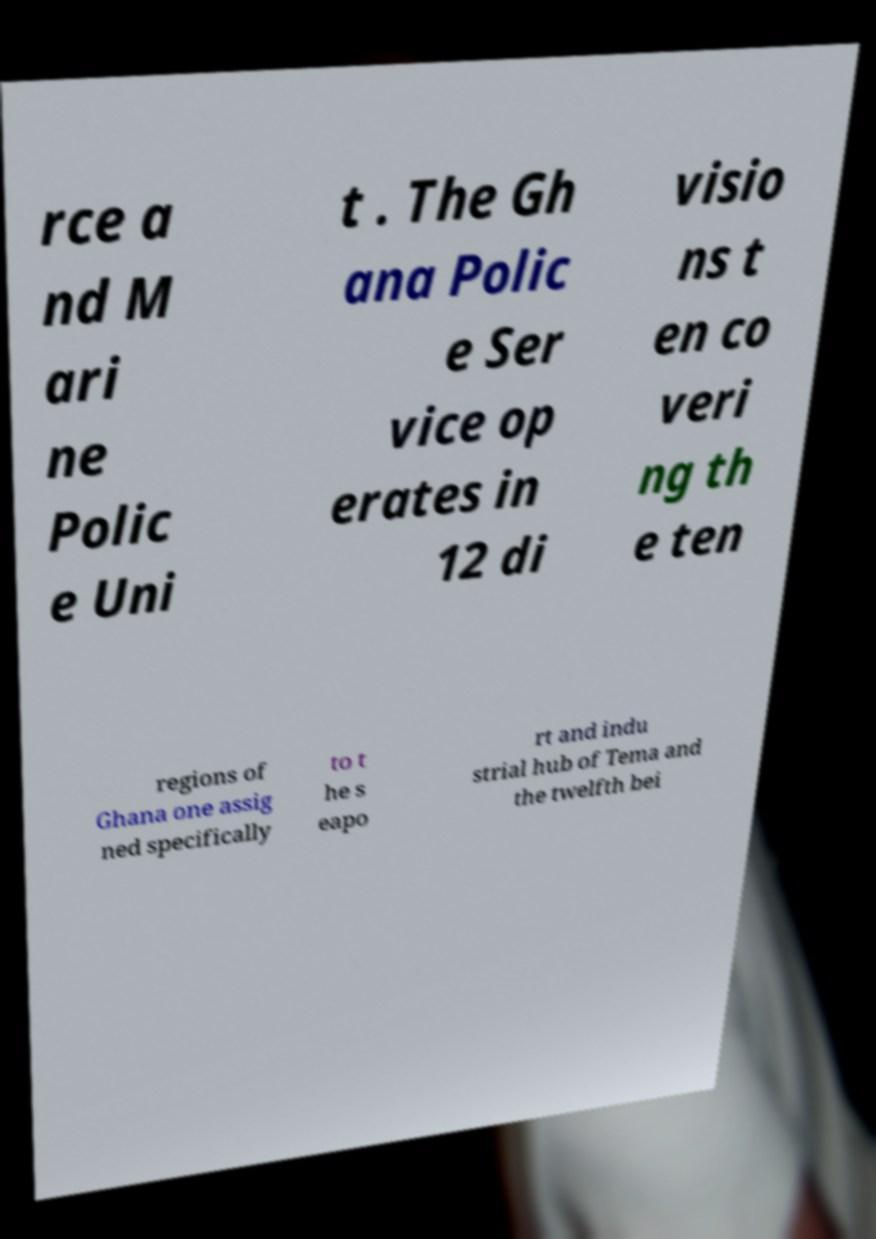There's text embedded in this image that I need extracted. Can you transcribe it verbatim? rce a nd M ari ne Polic e Uni t . The Gh ana Polic e Ser vice op erates in 12 di visio ns t en co veri ng th e ten regions of Ghana one assig ned specifically to t he s eapo rt and indu strial hub of Tema and the twelfth bei 